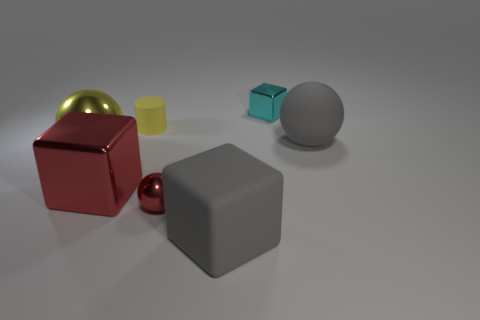Add 2 yellow shiny balls. How many objects exist? 9 Subtract all cylinders. How many objects are left? 6 Subtract 0 cyan cylinders. How many objects are left? 7 Subtract all big things. Subtract all big cylinders. How many objects are left? 3 Add 3 rubber spheres. How many rubber spheres are left? 4 Add 4 big purple blocks. How many big purple blocks exist? 4 